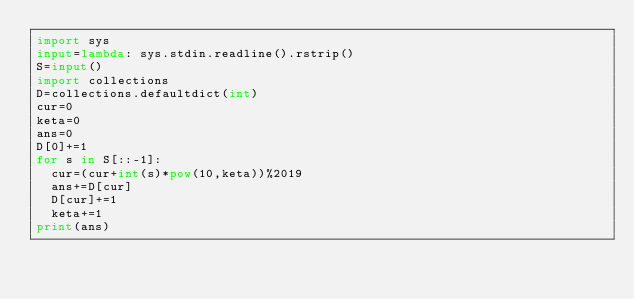<code> <loc_0><loc_0><loc_500><loc_500><_Python_>import sys
input=lambda: sys.stdin.readline().rstrip()
S=input()
import collections
D=collections.defaultdict(int)
cur=0
keta=0
ans=0
D[0]+=1
for s in S[::-1]:
  cur=(cur+int(s)*pow(10,keta))%2019
  ans+=D[cur]
  D[cur]+=1
  keta+=1
print(ans)</code> 